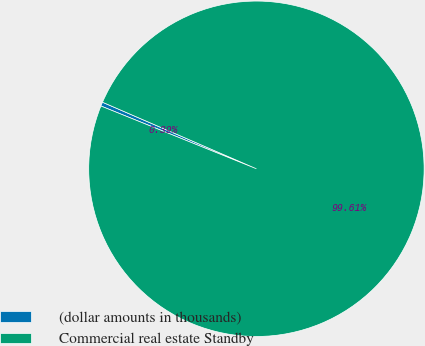Convert chart. <chart><loc_0><loc_0><loc_500><loc_500><pie_chart><fcel>(dollar amounts in thousands)<fcel>Commercial real estate Standby<nl><fcel>0.39%<fcel>99.61%<nl></chart> 